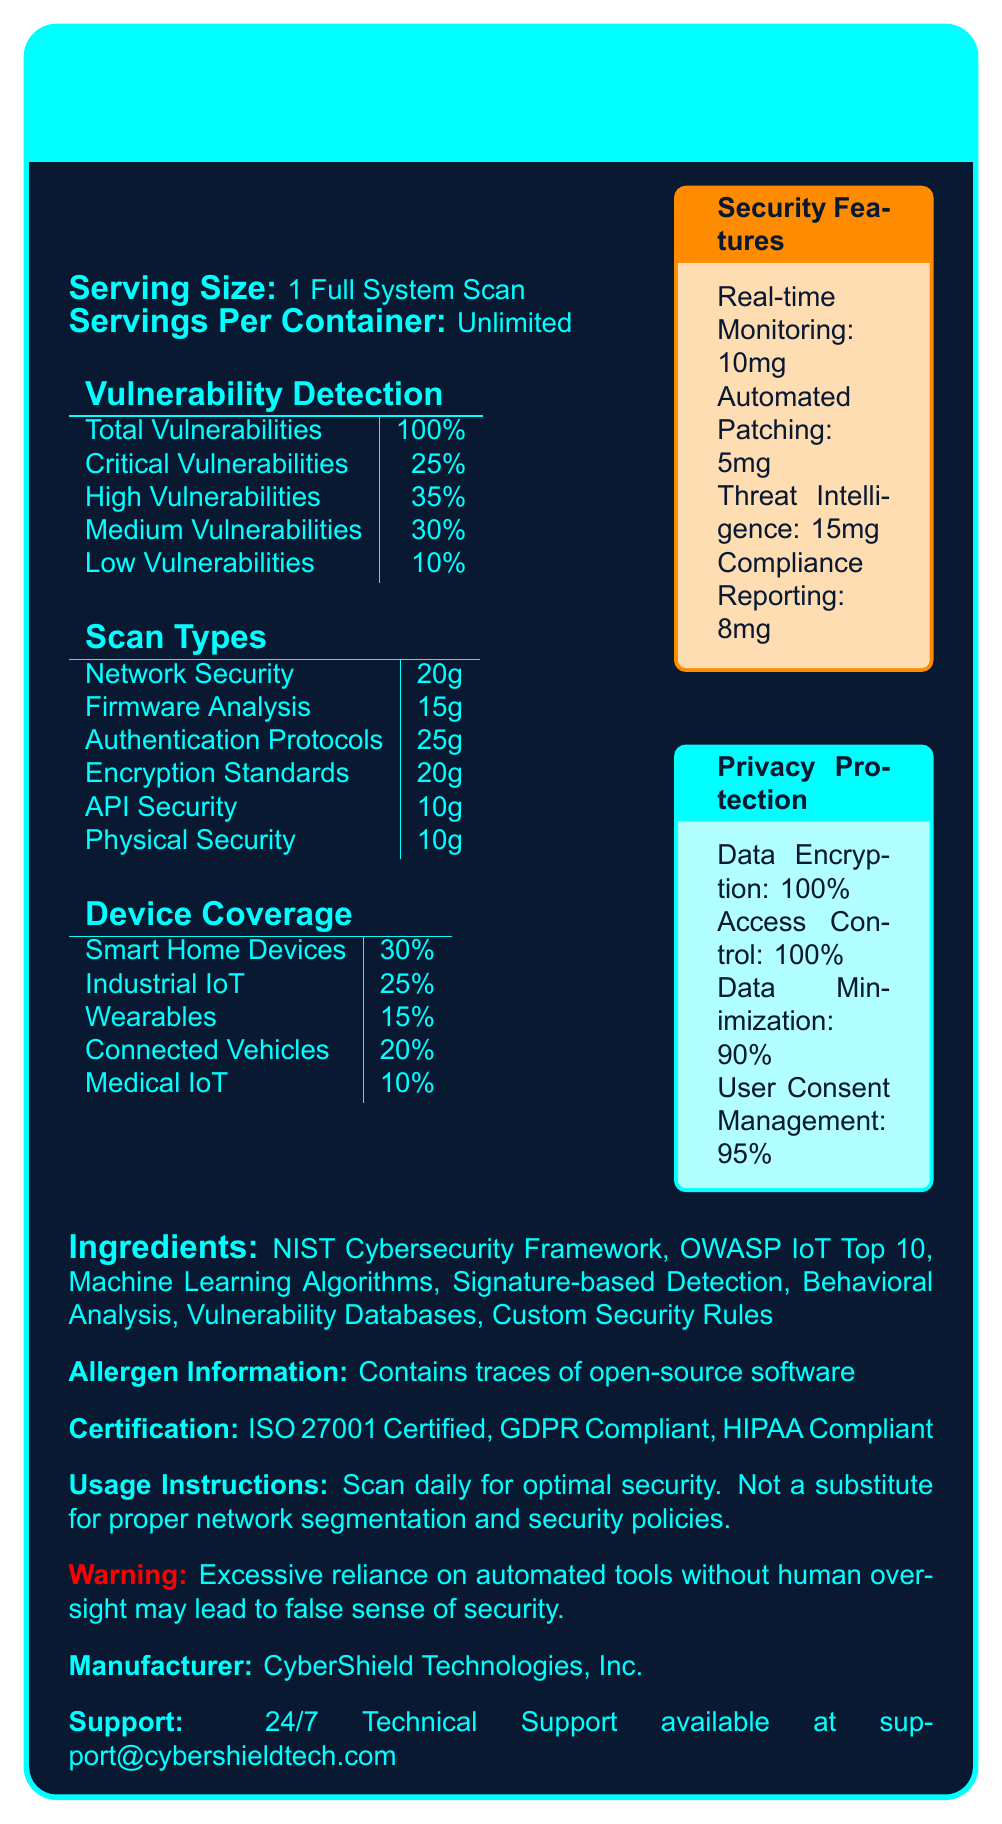What is the serving size for using IoTShieldScan Pro? The document states that the serving size is 1 Full System Scan.
Answer: 1 Full System Scan How many types of vulnerabilities does IoTShieldScan Pro detect? The document lists four types of vulnerabilities detected: Critical, High, Medium, and Low.
Answer: Four Which scan type is provided in the largest quantity? The document specifies that Authentication Protocols is provided in 25g, the largest quantity.
Answer: Authentication Protocols Does IoTShieldScan Pro cover security for Industrial IoT devices? The document shows that Industrial IoT devices have 25% coverage.
Answer: Yes What percentage of IoTShieldScan Pro's vulnerability detection is dedicated to Critical Vulnerabilities? The document lists that Critical Vulnerabilities detection accounts for 25%.
Answer: 25% Which of the following security features has the highest measurement in mg? A. Real-time Monitoring B. Automated Patching C. Threat Intelligence D. Compliance Reporting Threat Intelligence has 15mg, which is the highest among the listed features.
Answer: C. Threat Intelligence What certification does IoTShieldScan Pro have? A. ISO 9001 B. ISO 27001 C. PCI DSS D. SOC 2 The document states that IoTShieldScan Pro is ISO 27001 Certified.
Answer: B. ISO 27001 True or False: IoTShieldScan Pro is GDPR compliant. The document indicates that IoTShieldScan Pro is GDPR compliant.
Answer: True Summarize the main features and capabilities of IoTShieldScan Pro. The document provides a detailed overview of IoTShieldScan Pro's features and capabilities, including its vulnerability detection, scan types, device coverage, security features, privacy protection, certifications, usage instructions, and support information.
Answer: IoTShieldScan Pro offers comprehensive IoT device security assessment capabilities, including detection of various vulnerabilities, multiple scan types, coverage for different device categories, key security features, and privacy protection mechanisms. It is certified with ISO 27001, GDPR Compliant, and HIPAA Compliant, and provides 24/7 technical support. What are the ingredients used in IoTShieldScan Pro? The document lists these ingredients in the section labeled "Ingredients".
Answer: NIST Cybersecurity Framework, OWASP IoT Top 10, Machine Learning Algorithms, Signature-based Detection, Behavioral Analysis, Vulnerability Databases, Custom Security Rules How often should one perform a full system scan with IoTShieldScan Pro? The document states "Scan daily for optimal security."
Answer: Daily What warning is given about using IoTShieldScan Pro? The document provides this warning about relying solely on automated tools.
Answer: Excessive reliance on automated tools without human oversight may lead to a false sense of security. Who manufactures IoTShieldScan Pro? The document lists CyberShield Technologies, Inc. as the manufacturer.
Answer: CyberShield Technologies, Inc. Based on the document, how is privacy protection achieved in IoTShieldScan Pro? The document lists these features under the Privacy Protection section.
Answer: Through Data Encryption, Access Control, Data Minimization, and User Consent Management Can you access the IoTShieldScan Pro support team via phone? The document only mentions support availability via email at support@cybershieldtech.com, with no phone support details provided.
Answer: Not enough information 